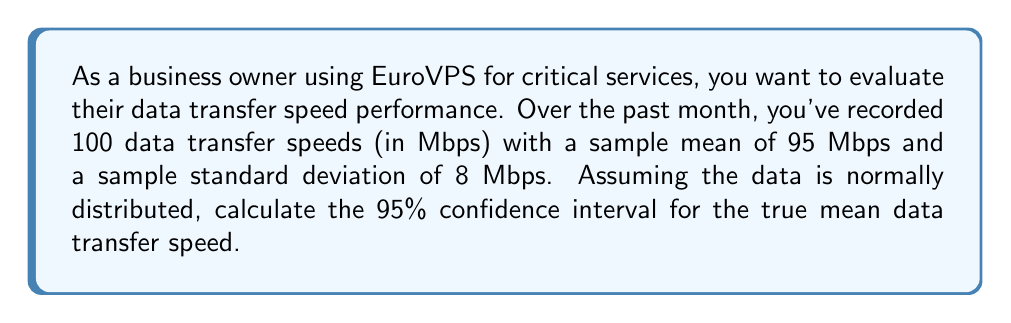Can you solve this math problem? To calculate the 95% confidence interval, we'll use the formula:

$$\bar{x} \pm t_{\frac{\alpha}{2}, n-1} \cdot \frac{s}{\sqrt{n}}$$

Where:
$\bar{x}$ = sample mean = 95 Mbps
$s$ = sample standard deviation = 8 Mbps
$n$ = sample size = 100
$t_{\frac{\alpha}{2}, n-1}$ = t-value for 95% confidence level with 99 degrees of freedom

Steps:
1) For a 95% confidence level, $\alpha = 0.05$
2) Degrees of freedom = $n - 1 = 99$
3) From t-table, $t_{0.025, 99} \approx 1.984$
4) Calculate the margin of error:
   $$1.984 \cdot \frac{8}{\sqrt{100}} = 1.984 \cdot 0.8 = 1.5872$$
5) Calculate the confidence interval:
   Lower bound: $95 - 1.5872 = 93.4128$
   Upper bound: $95 + 1.5872 = 96.5872$

Therefore, the 95% confidence interval is (93.4128, 96.5872) Mbps.
Answer: (93.4128, 96.5872) Mbps 